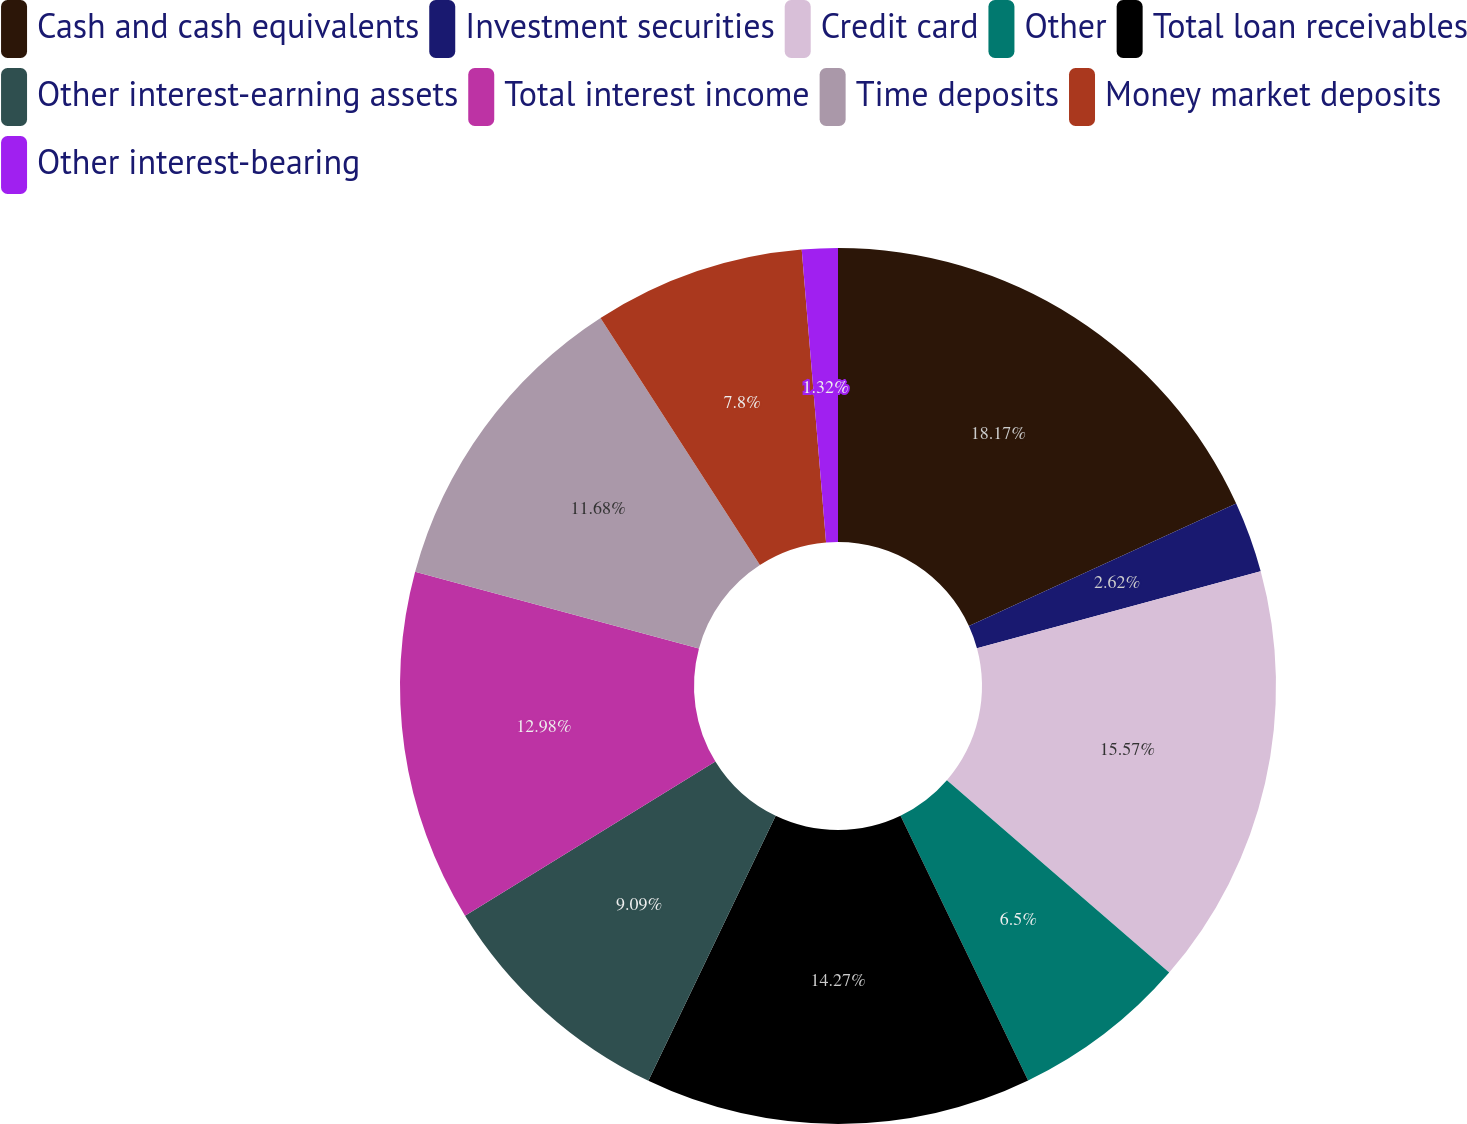Convert chart. <chart><loc_0><loc_0><loc_500><loc_500><pie_chart><fcel>Cash and cash equivalents<fcel>Investment securities<fcel>Credit card<fcel>Other<fcel>Total loan receivables<fcel>Other interest-earning assets<fcel>Total interest income<fcel>Time deposits<fcel>Money market deposits<fcel>Other interest-bearing<nl><fcel>18.16%<fcel>2.62%<fcel>15.57%<fcel>6.5%<fcel>14.27%<fcel>9.09%<fcel>12.98%<fcel>11.68%<fcel>7.8%<fcel>1.32%<nl></chart> 